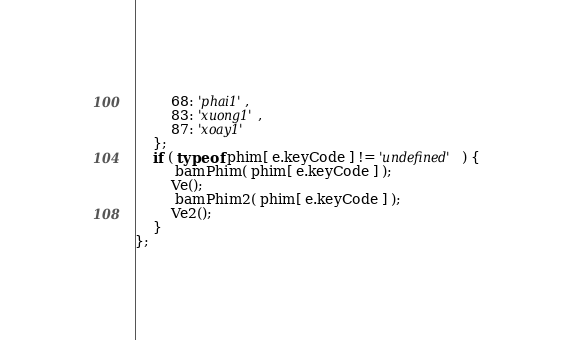<code> <loc_0><loc_0><loc_500><loc_500><_JavaScript_>        68: 'phai1',
        83: 'xuong1',
        87: 'xoay1'
    };
    if ( typeof phim[ e.keyCode ] != 'undefined' ) {
         bamPhim( phim[ e.keyCode ] );
        Ve(); 
         bamPhim2( phim[ e.keyCode ] );
        Ve2(); 
    }
};
</code> 